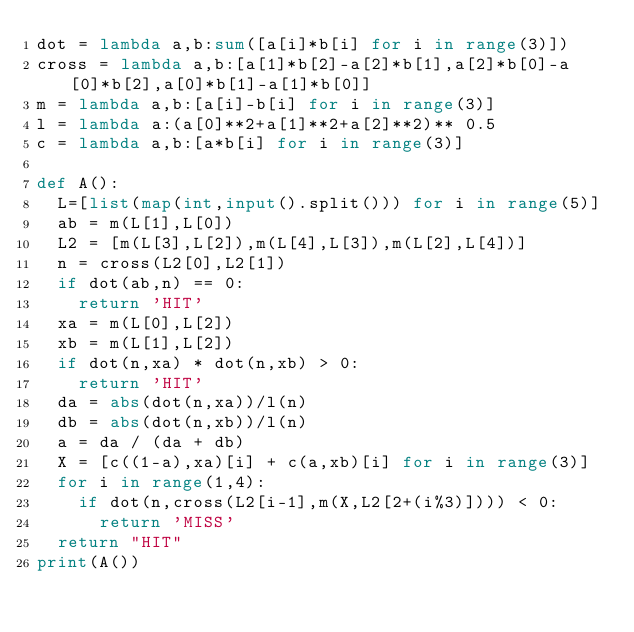<code> <loc_0><loc_0><loc_500><loc_500><_Python_>dot = lambda a,b:sum([a[i]*b[i] for i in range(3)])
cross = lambda a,b:[a[1]*b[2]-a[2]*b[1],a[2]*b[0]-a[0]*b[2],a[0]*b[1]-a[1]*b[0]]
m = lambda a,b:[a[i]-b[i] for i in range(3)]
l = lambda a:(a[0]**2+a[1]**2+a[2]**2)** 0.5
c = lambda a,b:[a*b[i] for i in range(3)]

def A():
  L=[list(map(int,input().split())) for i in range(5)]
  ab = m(L[1],L[0])
  L2 = [m(L[3],L[2]),m(L[4],L[3]),m(L[2],L[4])]
  n = cross(L2[0],L2[1])
  if dot(ab,n) == 0:
    return 'HIT'
  xa = m(L[0],L[2])
  xb = m(L[1],L[2])
  if dot(n,xa) * dot(n,xb) > 0:
    return 'HIT'
  da = abs(dot(n,xa))/l(n)
  db = abs(dot(n,xb))/l(n)
  a = da / (da + db)
  X = [c((1-a),xa)[i] + c(a,xb)[i] for i in range(3)]
  for i in range(1,4):
    if dot(n,cross(L2[i-1],m(X,L2[2+(i%3)]))) < 0:
      return 'MISS'
  return "HIT"
print(A())</code> 